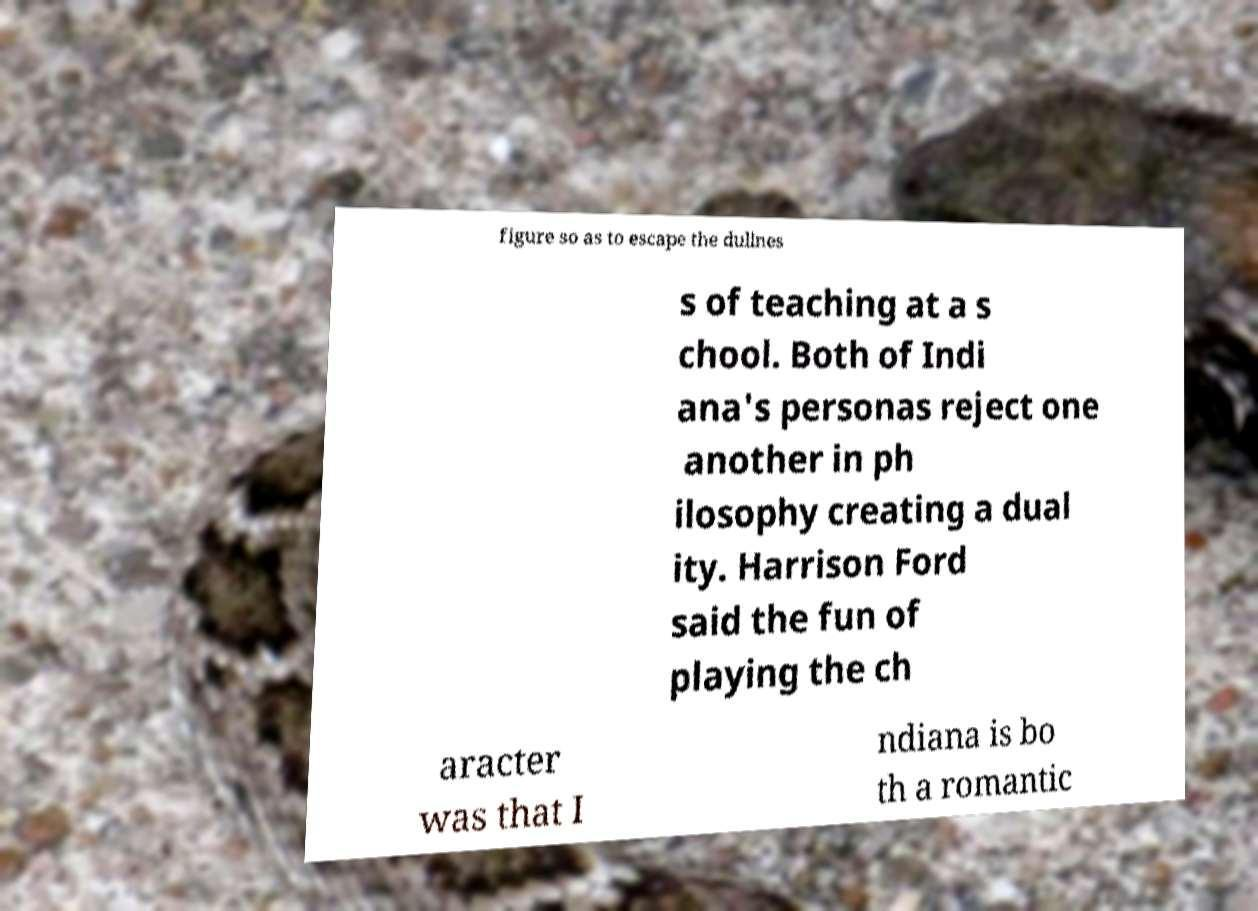I need the written content from this picture converted into text. Can you do that? figure so as to escape the dullnes s of teaching at a s chool. Both of Indi ana's personas reject one another in ph ilosophy creating a dual ity. Harrison Ford said the fun of playing the ch aracter was that I ndiana is bo th a romantic 